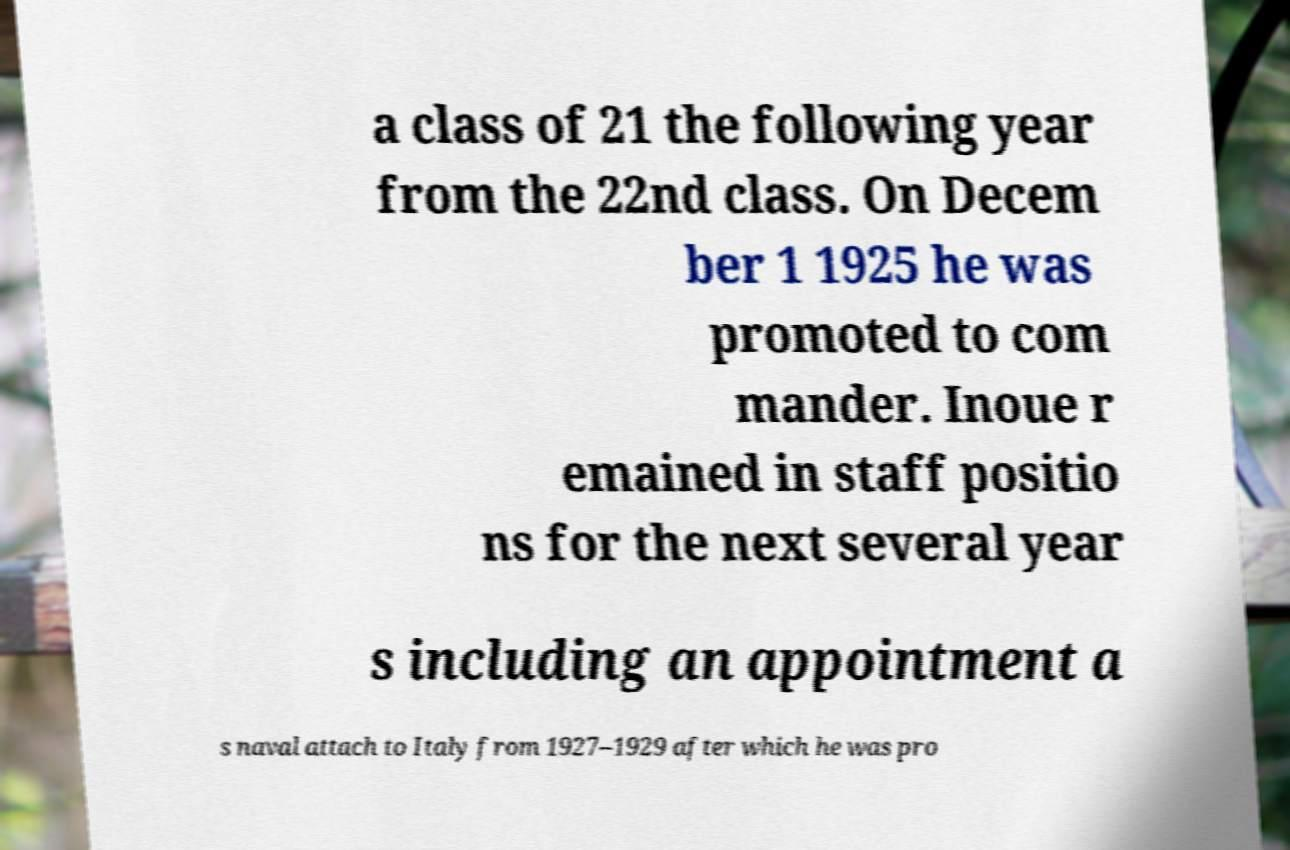Can you read and provide the text displayed in the image?This photo seems to have some interesting text. Can you extract and type it out for me? a class of 21 the following year from the 22nd class. On Decem ber 1 1925 he was promoted to com mander. Inoue r emained in staff positio ns for the next several year s including an appointment a s naval attach to Italy from 1927–1929 after which he was pro 